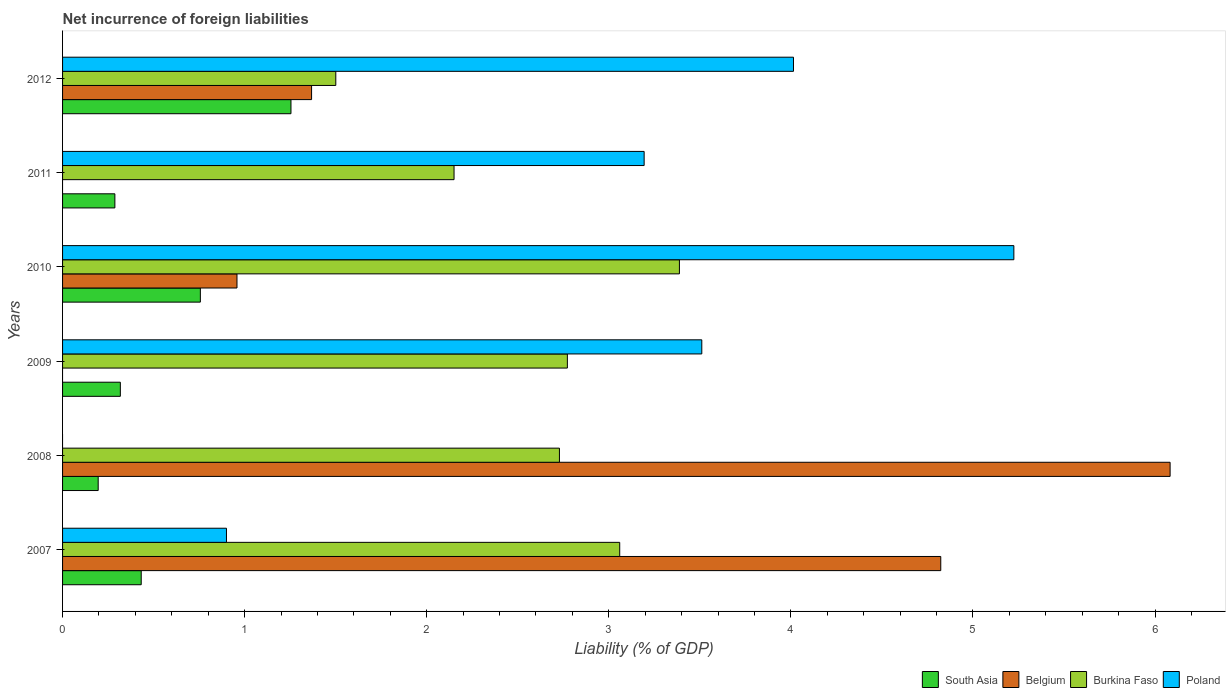How many different coloured bars are there?
Give a very brief answer. 4. Are the number of bars on each tick of the Y-axis equal?
Provide a short and direct response. No. How many bars are there on the 2nd tick from the top?
Your answer should be compact. 3. How many bars are there on the 1st tick from the bottom?
Give a very brief answer. 4. What is the net incurrence of foreign liabilities in Burkina Faso in 2007?
Keep it short and to the point. 3.06. Across all years, what is the maximum net incurrence of foreign liabilities in Belgium?
Provide a succinct answer. 6.08. In which year was the net incurrence of foreign liabilities in Burkina Faso maximum?
Your answer should be compact. 2010. What is the total net incurrence of foreign liabilities in South Asia in the graph?
Ensure brevity in your answer.  3.24. What is the difference between the net incurrence of foreign liabilities in Poland in 2010 and that in 2011?
Ensure brevity in your answer.  2.03. What is the difference between the net incurrence of foreign liabilities in Poland in 2011 and the net incurrence of foreign liabilities in Belgium in 2007?
Provide a succinct answer. -1.63. What is the average net incurrence of foreign liabilities in Burkina Faso per year?
Offer a terse response. 2.6. In the year 2009, what is the difference between the net incurrence of foreign liabilities in Poland and net incurrence of foreign liabilities in Burkina Faso?
Make the answer very short. 0.74. What is the ratio of the net incurrence of foreign liabilities in Belgium in 2008 to that in 2010?
Provide a short and direct response. 6.35. Is the difference between the net incurrence of foreign liabilities in Poland in 2007 and 2012 greater than the difference between the net incurrence of foreign liabilities in Burkina Faso in 2007 and 2012?
Your response must be concise. No. What is the difference between the highest and the second highest net incurrence of foreign liabilities in Belgium?
Your response must be concise. 1.26. What is the difference between the highest and the lowest net incurrence of foreign liabilities in South Asia?
Ensure brevity in your answer.  1.06. In how many years, is the net incurrence of foreign liabilities in Burkina Faso greater than the average net incurrence of foreign liabilities in Burkina Faso taken over all years?
Ensure brevity in your answer.  4. Is the sum of the net incurrence of foreign liabilities in Poland in 2007 and 2010 greater than the maximum net incurrence of foreign liabilities in Burkina Faso across all years?
Offer a very short reply. Yes. Is it the case that in every year, the sum of the net incurrence of foreign liabilities in Poland and net incurrence of foreign liabilities in Burkina Faso is greater than the sum of net incurrence of foreign liabilities in Belgium and net incurrence of foreign liabilities in South Asia?
Offer a terse response. No. How many bars are there?
Ensure brevity in your answer.  21. What is the difference between two consecutive major ticks on the X-axis?
Your answer should be compact. 1. Are the values on the major ticks of X-axis written in scientific E-notation?
Provide a succinct answer. No. Does the graph contain any zero values?
Ensure brevity in your answer.  Yes. Does the graph contain grids?
Offer a very short reply. No. Where does the legend appear in the graph?
Offer a terse response. Bottom right. How are the legend labels stacked?
Ensure brevity in your answer.  Horizontal. What is the title of the graph?
Ensure brevity in your answer.  Net incurrence of foreign liabilities. What is the label or title of the X-axis?
Provide a succinct answer. Liability (% of GDP). What is the Liability (% of GDP) of South Asia in 2007?
Offer a very short reply. 0.43. What is the Liability (% of GDP) of Belgium in 2007?
Ensure brevity in your answer.  4.82. What is the Liability (% of GDP) in Burkina Faso in 2007?
Offer a very short reply. 3.06. What is the Liability (% of GDP) in Poland in 2007?
Provide a short and direct response. 0.9. What is the Liability (% of GDP) in South Asia in 2008?
Your answer should be very brief. 0.2. What is the Liability (% of GDP) in Belgium in 2008?
Make the answer very short. 6.08. What is the Liability (% of GDP) in Burkina Faso in 2008?
Offer a terse response. 2.73. What is the Liability (% of GDP) in South Asia in 2009?
Offer a terse response. 0.32. What is the Liability (% of GDP) in Belgium in 2009?
Provide a short and direct response. 0. What is the Liability (% of GDP) in Burkina Faso in 2009?
Ensure brevity in your answer.  2.77. What is the Liability (% of GDP) in Poland in 2009?
Offer a very short reply. 3.51. What is the Liability (% of GDP) in South Asia in 2010?
Give a very brief answer. 0.76. What is the Liability (% of GDP) in Belgium in 2010?
Offer a terse response. 0.96. What is the Liability (% of GDP) of Burkina Faso in 2010?
Your answer should be compact. 3.39. What is the Liability (% of GDP) of Poland in 2010?
Provide a succinct answer. 5.22. What is the Liability (% of GDP) of South Asia in 2011?
Keep it short and to the point. 0.29. What is the Liability (% of GDP) of Belgium in 2011?
Ensure brevity in your answer.  0. What is the Liability (% of GDP) in Burkina Faso in 2011?
Provide a short and direct response. 2.15. What is the Liability (% of GDP) in Poland in 2011?
Provide a short and direct response. 3.19. What is the Liability (% of GDP) in South Asia in 2012?
Your response must be concise. 1.25. What is the Liability (% of GDP) in Belgium in 2012?
Make the answer very short. 1.37. What is the Liability (% of GDP) of Burkina Faso in 2012?
Your response must be concise. 1.5. What is the Liability (% of GDP) of Poland in 2012?
Offer a very short reply. 4.01. Across all years, what is the maximum Liability (% of GDP) of South Asia?
Your response must be concise. 1.25. Across all years, what is the maximum Liability (% of GDP) of Belgium?
Give a very brief answer. 6.08. Across all years, what is the maximum Liability (% of GDP) of Burkina Faso?
Offer a terse response. 3.39. Across all years, what is the maximum Liability (% of GDP) in Poland?
Make the answer very short. 5.22. Across all years, what is the minimum Liability (% of GDP) in South Asia?
Your answer should be very brief. 0.2. Across all years, what is the minimum Liability (% of GDP) in Burkina Faso?
Keep it short and to the point. 1.5. Across all years, what is the minimum Liability (% of GDP) of Poland?
Make the answer very short. 0. What is the total Liability (% of GDP) of South Asia in the graph?
Ensure brevity in your answer.  3.24. What is the total Liability (% of GDP) in Belgium in the graph?
Offer a terse response. 13.23. What is the total Liability (% of GDP) in Burkina Faso in the graph?
Offer a terse response. 15.6. What is the total Liability (% of GDP) in Poland in the graph?
Your response must be concise. 16.84. What is the difference between the Liability (% of GDP) of South Asia in 2007 and that in 2008?
Your answer should be very brief. 0.24. What is the difference between the Liability (% of GDP) in Belgium in 2007 and that in 2008?
Keep it short and to the point. -1.26. What is the difference between the Liability (% of GDP) of Burkina Faso in 2007 and that in 2008?
Make the answer very short. 0.33. What is the difference between the Liability (% of GDP) of South Asia in 2007 and that in 2009?
Provide a short and direct response. 0.11. What is the difference between the Liability (% of GDP) of Burkina Faso in 2007 and that in 2009?
Keep it short and to the point. 0.29. What is the difference between the Liability (% of GDP) of Poland in 2007 and that in 2009?
Keep it short and to the point. -2.61. What is the difference between the Liability (% of GDP) in South Asia in 2007 and that in 2010?
Keep it short and to the point. -0.32. What is the difference between the Liability (% of GDP) of Belgium in 2007 and that in 2010?
Ensure brevity in your answer.  3.87. What is the difference between the Liability (% of GDP) in Burkina Faso in 2007 and that in 2010?
Offer a very short reply. -0.33. What is the difference between the Liability (% of GDP) in Poland in 2007 and that in 2010?
Provide a short and direct response. -4.32. What is the difference between the Liability (% of GDP) of South Asia in 2007 and that in 2011?
Your answer should be very brief. 0.14. What is the difference between the Liability (% of GDP) of Burkina Faso in 2007 and that in 2011?
Give a very brief answer. 0.91. What is the difference between the Liability (% of GDP) of Poland in 2007 and that in 2011?
Provide a succinct answer. -2.29. What is the difference between the Liability (% of GDP) in South Asia in 2007 and that in 2012?
Provide a succinct answer. -0.82. What is the difference between the Liability (% of GDP) in Belgium in 2007 and that in 2012?
Give a very brief answer. 3.46. What is the difference between the Liability (% of GDP) in Burkina Faso in 2007 and that in 2012?
Give a very brief answer. 1.56. What is the difference between the Liability (% of GDP) in Poland in 2007 and that in 2012?
Give a very brief answer. -3.11. What is the difference between the Liability (% of GDP) in South Asia in 2008 and that in 2009?
Ensure brevity in your answer.  -0.12. What is the difference between the Liability (% of GDP) of Burkina Faso in 2008 and that in 2009?
Your answer should be compact. -0.04. What is the difference between the Liability (% of GDP) of South Asia in 2008 and that in 2010?
Your response must be concise. -0.56. What is the difference between the Liability (% of GDP) of Belgium in 2008 and that in 2010?
Your answer should be compact. 5.12. What is the difference between the Liability (% of GDP) of Burkina Faso in 2008 and that in 2010?
Your answer should be very brief. -0.66. What is the difference between the Liability (% of GDP) of South Asia in 2008 and that in 2011?
Offer a very short reply. -0.09. What is the difference between the Liability (% of GDP) of Burkina Faso in 2008 and that in 2011?
Keep it short and to the point. 0.58. What is the difference between the Liability (% of GDP) of South Asia in 2008 and that in 2012?
Provide a succinct answer. -1.06. What is the difference between the Liability (% of GDP) in Belgium in 2008 and that in 2012?
Your answer should be compact. 4.72. What is the difference between the Liability (% of GDP) in Burkina Faso in 2008 and that in 2012?
Your response must be concise. 1.23. What is the difference between the Liability (% of GDP) in South Asia in 2009 and that in 2010?
Provide a short and direct response. -0.44. What is the difference between the Liability (% of GDP) of Burkina Faso in 2009 and that in 2010?
Keep it short and to the point. -0.62. What is the difference between the Liability (% of GDP) in Poland in 2009 and that in 2010?
Give a very brief answer. -1.71. What is the difference between the Liability (% of GDP) of Burkina Faso in 2009 and that in 2011?
Make the answer very short. 0.62. What is the difference between the Liability (% of GDP) in Poland in 2009 and that in 2011?
Your response must be concise. 0.32. What is the difference between the Liability (% of GDP) of South Asia in 2009 and that in 2012?
Provide a short and direct response. -0.94. What is the difference between the Liability (% of GDP) of Burkina Faso in 2009 and that in 2012?
Ensure brevity in your answer.  1.27. What is the difference between the Liability (% of GDP) in Poland in 2009 and that in 2012?
Your answer should be compact. -0.5. What is the difference between the Liability (% of GDP) in South Asia in 2010 and that in 2011?
Ensure brevity in your answer.  0.47. What is the difference between the Liability (% of GDP) of Burkina Faso in 2010 and that in 2011?
Offer a terse response. 1.24. What is the difference between the Liability (% of GDP) in Poland in 2010 and that in 2011?
Keep it short and to the point. 2.03. What is the difference between the Liability (% of GDP) of South Asia in 2010 and that in 2012?
Keep it short and to the point. -0.5. What is the difference between the Liability (% of GDP) of Belgium in 2010 and that in 2012?
Provide a short and direct response. -0.41. What is the difference between the Liability (% of GDP) in Burkina Faso in 2010 and that in 2012?
Provide a succinct answer. 1.89. What is the difference between the Liability (% of GDP) in Poland in 2010 and that in 2012?
Your answer should be very brief. 1.21. What is the difference between the Liability (% of GDP) of South Asia in 2011 and that in 2012?
Keep it short and to the point. -0.97. What is the difference between the Liability (% of GDP) in Burkina Faso in 2011 and that in 2012?
Offer a very short reply. 0.65. What is the difference between the Liability (% of GDP) in Poland in 2011 and that in 2012?
Make the answer very short. -0.82. What is the difference between the Liability (% of GDP) in South Asia in 2007 and the Liability (% of GDP) in Belgium in 2008?
Make the answer very short. -5.65. What is the difference between the Liability (% of GDP) in South Asia in 2007 and the Liability (% of GDP) in Burkina Faso in 2008?
Offer a very short reply. -2.3. What is the difference between the Liability (% of GDP) of Belgium in 2007 and the Liability (% of GDP) of Burkina Faso in 2008?
Keep it short and to the point. 2.09. What is the difference between the Liability (% of GDP) of South Asia in 2007 and the Liability (% of GDP) of Burkina Faso in 2009?
Give a very brief answer. -2.34. What is the difference between the Liability (% of GDP) in South Asia in 2007 and the Liability (% of GDP) in Poland in 2009?
Provide a short and direct response. -3.08. What is the difference between the Liability (% of GDP) in Belgium in 2007 and the Liability (% of GDP) in Burkina Faso in 2009?
Provide a short and direct response. 2.05. What is the difference between the Liability (% of GDP) of Belgium in 2007 and the Liability (% of GDP) of Poland in 2009?
Make the answer very short. 1.31. What is the difference between the Liability (% of GDP) in Burkina Faso in 2007 and the Liability (% of GDP) in Poland in 2009?
Ensure brevity in your answer.  -0.45. What is the difference between the Liability (% of GDP) of South Asia in 2007 and the Liability (% of GDP) of Belgium in 2010?
Ensure brevity in your answer.  -0.53. What is the difference between the Liability (% of GDP) of South Asia in 2007 and the Liability (% of GDP) of Burkina Faso in 2010?
Your answer should be compact. -2.96. What is the difference between the Liability (% of GDP) in South Asia in 2007 and the Liability (% of GDP) in Poland in 2010?
Ensure brevity in your answer.  -4.79. What is the difference between the Liability (% of GDP) in Belgium in 2007 and the Liability (% of GDP) in Burkina Faso in 2010?
Your response must be concise. 1.44. What is the difference between the Liability (% of GDP) in Belgium in 2007 and the Liability (% of GDP) in Poland in 2010?
Provide a succinct answer. -0.4. What is the difference between the Liability (% of GDP) of Burkina Faso in 2007 and the Liability (% of GDP) of Poland in 2010?
Offer a very short reply. -2.16. What is the difference between the Liability (% of GDP) of South Asia in 2007 and the Liability (% of GDP) of Burkina Faso in 2011?
Your response must be concise. -1.72. What is the difference between the Liability (% of GDP) of South Asia in 2007 and the Liability (% of GDP) of Poland in 2011?
Your answer should be compact. -2.76. What is the difference between the Liability (% of GDP) in Belgium in 2007 and the Liability (% of GDP) in Burkina Faso in 2011?
Offer a very short reply. 2.67. What is the difference between the Liability (% of GDP) in Belgium in 2007 and the Liability (% of GDP) in Poland in 2011?
Ensure brevity in your answer.  1.63. What is the difference between the Liability (% of GDP) of Burkina Faso in 2007 and the Liability (% of GDP) of Poland in 2011?
Your answer should be very brief. -0.13. What is the difference between the Liability (% of GDP) in South Asia in 2007 and the Liability (% of GDP) in Belgium in 2012?
Offer a terse response. -0.94. What is the difference between the Liability (% of GDP) in South Asia in 2007 and the Liability (% of GDP) in Burkina Faso in 2012?
Offer a terse response. -1.07. What is the difference between the Liability (% of GDP) in South Asia in 2007 and the Liability (% of GDP) in Poland in 2012?
Provide a succinct answer. -3.58. What is the difference between the Liability (% of GDP) of Belgium in 2007 and the Liability (% of GDP) of Burkina Faso in 2012?
Ensure brevity in your answer.  3.32. What is the difference between the Liability (% of GDP) of Belgium in 2007 and the Liability (% of GDP) of Poland in 2012?
Your answer should be very brief. 0.81. What is the difference between the Liability (% of GDP) of Burkina Faso in 2007 and the Liability (% of GDP) of Poland in 2012?
Give a very brief answer. -0.95. What is the difference between the Liability (% of GDP) in South Asia in 2008 and the Liability (% of GDP) in Burkina Faso in 2009?
Give a very brief answer. -2.58. What is the difference between the Liability (% of GDP) of South Asia in 2008 and the Liability (% of GDP) of Poland in 2009?
Your response must be concise. -3.32. What is the difference between the Liability (% of GDP) of Belgium in 2008 and the Liability (% of GDP) of Burkina Faso in 2009?
Your answer should be very brief. 3.31. What is the difference between the Liability (% of GDP) of Belgium in 2008 and the Liability (% of GDP) of Poland in 2009?
Give a very brief answer. 2.57. What is the difference between the Liability (% of GDP) in Burkina Faso in 2008 and the Liability (% of GDP) in Poland in 2009?
Your answer should be very brief. -0.78. What is the difference between the Liability (% of GDP) in South Asia in 2008 and the Liability (% of GDP) in Belgium in 2010?
Your answer should be very brief. -0.76. What is the difference between the Liability (% of GDP) of South Asia in 2008 and the Liability (% of GDP) of Burkina Faso in 2010?
Provide a succinct answer. -3.19. What is the difference between the Liability (% of GDP) in South Asia in 2008 and the Liability (% of GDP) in Poland in 2010?
Make the answer very short. -5.03. What is the difference between the Liability (% of GDP) in Belgium in 2008 and the Liability (% of GDP) in Burkina Faso in 2010?
Offer a very short reply. 2.69. What is the difference between the Liability (% of GDP) in Belgium in 2008 and the Liability (% of GDP) in Poland in 2010?
Offer a very short reply. 0.86. What is the difference between the Liability (% of GDP) of Burkina Faso in 2008 and the Liability (% of GDP) of Poland in 2010?
Offer a terse response. -2.5. What is the difference between the Liability (% of GDP) in South Asia in 2008 and the Liability (% of GDP) in Burkina Faso in 2011?
Make the answer very short. -1.95. What is the difference between the Liability (% of GDP) in South Asia in 2008 and the Liability (% of GDP) in Poland in 2011?
Your answer should be compact. -3. What is the difference between the Liability (% of GDP) in Belgium in 2008 and the Liability (% of GDP) in Burkina Faso in 2011?
Ensure brevity in your answer.  3.93. What is the difference between the Liability (% of GDP) of Belgium in 2008 and the Liability (% of GDP) of Poland in 2011?
Ensure brevity in your answer.  2.89. What is the difference between the Liability (% of GDP) of Burkina Faso in 2008 and the Liability (% of GDP) of Poland in 2011?
Offer a very short reply. -0.47. What is the difference between the Liability (% of GDP) of South Asia in 2008 and the Liability (% of GDP) of Belgium in 2012?
Keep it short and to the point. -1.17. What is the difference between the Liability (% of GDP) of South Asia in 2008 and the Liability (% of GDP) of Burkina Faso in 2012?
Keep it short and to the point. -1.3. What is the difference between the Liability (% of GDP) in South Asia in 2008 and the Liability (% of GDP) in Poland in 2012?
Ensure brevity in your answer.  -3.82. What is the difference between the Liability (% of GDP) of Belgium in 2008 and the Liability (% of GDP) of Burkina Faso in 2012?
Ensure brevity in your answer.  4.58. What is the difference between the Liability (% of GDP) of Belgium in 2008 and the Liability (% of GDP) of Poland in 2012?
Your answer should be compact. 2.07. What is the difference between the Liability (% of GDP) in Burkina Faso in 2008 and the Liability (% of GDP) in Poland in 2012?
Provide a succinct answer. -1.29. What is the difference between the Liability (% of GDP) in South Asia in 2009 and the Liability (% of GDP) in Belgium in 2010?
Your answer should be very brief. -0.64. What is the difference between the Liability (% of GDP) in South Asia in 2009 and the Liability (% of GDP) in Burkina Faso in 2010?
Provide a succinct answer. -3.07. What is the difference between the Liability (% of GDP) of South Asia in 2009 and the Liability (% of GDP) of Poland in 2010?
Your answer should be compact. -4.91. What is the difference between the Liability (% of GDP) in Burkina Faso in 2009 and the Liability (% of GDP) in Poland in 2010?
Offer a terse response. -2.45. What is the difference between the Liability (% of GDP) in South Asia in 2009 and the Liability (% of GDP) in Burkina Faso in 2011?
Your answer should be very brief. -1.83. What is the difference between the Liability (% of GDP) in South Asia in 2009 and the Liability (% of GDP) in Poland in 2011?
Keep it short and to the point. -2.88. What is the difference between the Liability (% of GDP) of Burkina Faso in 2009 and the Liability (% of GDP) of Poland in 2011?
Provide a succinct answer. -0.42. What is the difference between the Liability (% of GDP) in South Asia in 2009 and the Liability (% of GDP) in Belgium in 2012?
Provide a succinct answer. -1.05. What is the difference between the Liability (% of GDP) of South Asia in 2009 and the Liability (% of GDP) of Burkina Faso in 2012?
Keep it short and to the point. -1.18. What is the difference between the Liability (% of GDP) in South Asia in 2009 and the Liability (% of GDP) in Poland in 2012?
Your answer should be very brief. -3.7. What is the difference between the Liability (% of GDP) in Burkina Faso in 2009 and the Liability (% of GDP) in Poland in 2012?
Provide a short and direct response. -1.24. What is the difference between the Liability (% of GDP) of South Asia in 2010 and the Liability (% of GDP) of Burkina Faso in 2011?
Your answer should be very brief. -1.39. What is the difference between the Liability (% of GDP) of South Asia in 2010 and the Liability (% of GDP) of Poland in 2011?
Your answer should be very brief. -2.44. What is the difference between the Liability (% of GDP) of Belgium in 2010 and the Liability (% of GDP) of Burkina Faso in 2011?
Offer a terse response. -1.19. What is the difference between the Liability (% of GDP) in Belgium in 2010 and the Liability (% of GDP) in Poland in 2011?
Your answer should be very brief. -2.24. What is the difference between the Liability (% of GDP) in Burkina Faso in 2010 and the Liability (% of GDP) in Poland in 2011?
Ensure brevity in your answer.  0.19. What is the difference between the Liability (% of GDP) of South Asia in 2010 and the Liability (% of GDP) of Belgium in 2012?
Offer a very short reply. -0.61. What is the difference between the Liability (% of GDP) of South Asia in 2010 and the Liability (% of GDP) of Burkina Faso in 2012?
Keep it short and to the point. -0.74. What is the difference between the Liability (% of GDP) of South Asia in 2010 and the Liability (% of GDP) of Poland in 2012?
Your answer should be very brief. -3.26. What is the difference between the Liability (% of GDP) in Belgium in 2010 and the Liability (% of GDP) in Burkina Faso in 2012?
Offer a very short reply. -0.54. What is the difference between the Liability (% of GDP) of Belgium in 2010 and the Liability (% of GDP) of Poland in 2012?
Provide a succinct answer. -3.06. What is the difference between the Liability (% of GDP) in Burkina Faso in 2010 and the Liability (% of GDP) in Poland in 2012?
Make the answer very short. -0.63. What is the difference between the Liability (% of GDP) of South Asia in 2011 and the Liability (% of GDP) of Belgium in 2012?
Provide a succinct answer. -1.08. What is the difference between the Liability (% of GDP) of South Asia in 2011 and the Liability (% of GDP) of Burkina Faso in 2012?
Provide a succinct answer. -1.21. What is the difference between the Liability (% of GDP) of South Asia in 2011 and the Liability (% of GDP) of Poland in 2012?
Offer a very short reply. -3.73. What is the difference between the Liability (% of GDP) in Burkina Faso in 2011 and the Liability (% of GDP) in Poland in 2012?
Offer a terse response. -1.86. What is the average Liability (% of GDP) of South Asia per year?
Keep it short and to the point. 0.54. What is the average Liability (% of GDP) of Belgium per year?
Keep it short and to the point. 2.21. What is the average Liability (% of GDP) of Poland per year?
Offer a very short reply. 2.81. In the year 2007, what is the difference between the Liability (% of GDP) of South Asia and Liability (% of GDP) of Belgium?
Make the answer very short. -4.39. In the year 2007, what is the difference between the Liability (% of GDP) in South Asia and Liability (% of GDP) in Burkina Faso?
Make the answer very short. -2.63. In the year 2007, what is the difference between the Liability (% of GDP) of South Asia and Liability (% of GDP) of Poland?
Your answer should be compact. -0.47. In the year 2007, what is the difference between the Liability (% of GDP) in Belgium and Liability (% of GDP) in Burkina Faso?
Give a very brief answer. 1.76. In the year 2007, what is the difference between the Liability (% of GDP) in Belgium and Liability (% of GDP) in Poland?
Make the answer very short. 3.92. In the year 2007, what is the difference between the Liability (% of GDP) of Burkina Faso and Liability (% of GDP) of Poland?
Your response must be concise. 2.16. In the year 2008, what is the difference between the Liability (% of GDP) in South Asia and Liability (% of GDP) in Belgium?
Provide a succinct answer. -5.89. In the year 2008, what is the difference between the Liability (% of GDP) of South Asia and Liability (% of GDP) of Burkina Faso?
Your answer should be very brief. -2.53. In the year 2008, what is the difference between the Liability (% of GDP) of Belgium and Liability (% of GDP) of Burkina Faso?
Offer a very short reply. 3.35. In the year 2009, what is the difference between the Liability (% of GDP) in South Asia and Liability (% of GDP) in Burkina Faso?
Provide a succinct answer. -2.46. In the year 2009, what is the difference between the Liability (% of GDP) of South Asia and Liability (% of GDP) of Poland?
Offer a terse response. -3.19. In the year 2009, what is the difference between the Liability (% of GDP) of Burkina Faso and Liability (% of GDP) of Poland?
Offer a terse response. -0.74. In the year 2010, what is the difference between the Liability (% of GDP) of South Asia and Liability (% of GDP) of Belgium?
Your response must be concise. -0.2. In the year 2010, what is the difference between the Liability (% of GDP) of South Asia and Liability (% of GDP) of Burkina Faso?
Provide a succinct answer. -2.63. In the year 2010, what is the difference between the Liability (% of GDP) in South Asia and Liability (% of GDP) in Poland?
Your answer should be compact. -4.47. In the year 2010, what is the difference between the Liability (% of GDP) of Belgium and Liability (% of GDP) of Burkina Faso?
Ensure brevity in your answer.  -2.43. In the year 2010, what is the difference between the Liability (% of GDP) in Belgium and Liability (% of GDP) in Poland?
Provide a short and direct response. -4.27. In the year 2010, what is the difference between the Liability (% of GDP) of Burkina Faso and Liability (% of GDP) of Poland?
Provide a short and direct response. -1.84. In the year 2011, what is the difference between the Liability (% of GDP) in South Asia and Liability (% of GDP) in Burkina Faso?
Give a very brief answer. -1.86. In the year 2011, what is the difference between the Liability (% of GDP) of South Asia and Liability (% of GDP) of Poland?
Give a very brief answer. -2.91. In the year 2011, what is the difference between the Liability (% of GDP) in Burkina Faso and Liability (% of GDP) in Poland?
Keep it short and to the point. -1.04. In the year 2012, what is the difference between the Liability (% of GDP) of South Asia and Liability (% of GDP) of Belgium?
Provide a short and direct response. -0.11. In the year 2012, what is the difference between the Liability (% of GDP) of South Asia and Liability (% of GDP) of Burkina Faso?
Your response must be concise. -0.25. In the year 2012, what is the difference between the Liability (% of GDP) of South Asia and Liability (% of GDP) of Poland?
Offer a terse response. -2.76. In the year 2012, what is the difference between the Liability (% of GDP) in Belgium and Liability (% of GDP) in Burkina Faso?
Keep it short and to the point. -0.13. In the year 2012, what is the difference between the Liability (% of GDP) in Belgium and Liability (% of GDP) in Poland?
Your response must be concise. -2.65. In the year 2012, what is the difference between the Liability (% of GDP) of Burkina Faso and Liability (% of GDP) of Poland?
Your answer should be very brief. -2.51. What is the ratio of the Liability (% of GDP) in South Asia in 2007 to that in 2008?
Your answer should be very brief. 2.21. What is the ratio of the Liability (% of GDP) in Belgium in 2007 to that in 2008?
Your answer should be very brief. 0.79. What is the ratio of the Liability (% of GDP) of Burkina Faso in 2007 to that in 2008?
Offer a very short reply. 1.12. What is the ratio of the Liability (% of GDP) in South Asia in 2007 to that in 2009?
Provide a short and direct response. 1.36. What is the ratio of the Liability (% of GDP) of Burkina Faso in 2007 to that in 2009?
Your answer should be very brief. 1.1. What is the ratio of the Liability (% of GDP) in Poland in 2007 to that in 2009?
Keep it short and to the point. 0.26. What is the ratio of the Liability (% of GDP) in South Asia in 2007 to that in 2010?
Give a very brief answer. 0.57. What is the ratio of the Liability (% of GDP) of Belgium in 2007 to that in 2010?
Ensure brevity in your answer.  5.03. What is the ratio of the Liability (% of GDP) in Burkina Faso in 2007 to that in 2010?
Provide a succinct answer. 0.9. What is the ratio of the Liability (% of GDP) in Poland in 2007 to that in 2010?
Keep it short and to the point. 0.17. What is the ratio of the Liability (% of GDP) in South Asia in 2007 to that in 2011?
Provide a short and direct response. 1.5. What is the ratio of the Liability (% of GDP) of Burkina Faso in 2007 to that in 2011?
Provide a succinct answer. 1.42. What is the ratio of the Liability (% of GDP) in Poland in 2007 to that in 2011?
Keep it short and to the point. 0.28. What is the ratio of the Liability (% of GDP) in South Asia in 2007 to that in 2012?
Offer a very short reply. 0.34. What is the ratio of the Liability (% of GDP) in Belgium in 2007 to that in 2012?
Your answer should be very brief. 3.53. What is the ratio of the Liability (% of GDP) in Burkina Faso in 2007 to that in 2012?
Your response must be concise. 2.04. What is the ratio of the Liability (% of GDP) in Poland in 2007 to that in 2012?
Your answer should be compact. 0.22. What is the ratio of the Liability (% of GDP) in South Asia in 2008 to that in 2009?
Provide a succinct answer. 0.62. What is the ratio of the Liability (% of GDP) of Burkina Faso in 2008 to that in 2009?
Your response must be concise. 0.98. What is the ratio of the Liability (% of GDP) of South Asia in 2008 to that in 2010?
Give a very brief answer. 0.26. What is the ratio of the Liability (% of GDP) in Belgium in 2008 to that in 2010?
Provide a succinct answer. 6.35. What is the ratio of the Liability (% of GDP) of Burkina Faso in 2008 to that in 2010?
Keep it short and to the point. 0.81. What is the ratio of the Liability (% of GDP) in South Asia in 2008 to that in 2011?
Keep it short and to the point. 0.68. What is the ratio of the Liability (% of GDP) of Burkina Faso in 2008 to that in 2011?
Offer a terse response. 1.27. What is the ratio of the Liability (% of GDP) of South Asia in 2008 to that in 2012?
Provide a short and direct response. 0.16. What is the ratio of the Liability (% of GDP) in Belgium in 2008 to that in 2012?
Your response must be concise. 4.45. What is the ratio of the Liability (% of GDP) in Burkina Faso in 2008 to that in 2012?
Keep it short and to the point. 1.82. What is the ratio of the Liability (% of GDP) of South Asia in 2009 to that in 2010?
Your answer should be very brief. 0.42. What is the ratio of the Liability (% of GDP) of Burkina Faso in 2009 to that in 2010?
Provide a short and direct response. 0.82. What is the ratio of the Liability (% of GDP) of Poland in 2009 to that in 2010?
Keep it short and to the point. 0.67. What is the ratio of the Liability (% of GDP) in South Asia in 2009 to that in 2011?
Your answer should be very brief. 1.1. What is the ratio of the Liability (% of GDP) of Burkina Faso in 2009 to that in 2011?
Offer a very short reply. 1.29. What is the ratio of the Liability (% of GDP) of Poland in 2009 to that in 2011?
Offer a terse response. 1.1. What is the ratio of the Liability (% of GDP) in South Asia in 2009 to that in 2012?
Offer a terse response. 0.25. What is the ratio of the Liability (% of GDP) in Burkina Faso in 2009 to that in 2012?
Provide a short and direct response. 1.85. What is the ratio of the Liability (% of GDP) in Poland in 2009 to that in 2012?
Provide a short and direct response. 0.87. What is the ratio of the Liability (% of GDP) in South Asia in 2010 to that in 2011?
Your response must be concise. 2.63. What is the ratio of the Liability (% of GDP) in Burkina Faso in 2010 to that in 2011?
Your response must be concise. 1.58. What is the ratio of the Liability (% of GDP) of Poland in 2010 to that in 2011?
Keep it short and to the point. 1.64. What is the ratio of the Liability (% of GDP) in South Asia in 2010 to that in 2012?
Offer a terse response. 0.6. What is the ratio of the Liability (% of GDP) in Belgium in 2010 to that in 2012?
Ensure brevity in your answer.  0.7. What is the ratio of the Liability (% of GDP) in Burkina Faso in 2010 to that in 2012?
Provide a succinct answer. 2.26. What is the ratio of the Liability (% of GDP) of Poland in 2010 to that in 2012?
Keep it short and to the point. 1.3. What is the ratio of the Liability (% of GDP) in South Asia in 2011 to that in 2012?
Your answer should be very brief. 0.23. What is the ratio of the Liability (% of GDP) in Burkina Faso in 2011 to that in 2012?
Provide a short and direct response. 1.43. What is the ratio of the Liability (% of GDP) of Poland in 2011 to that in 2012?
Offer a very short reply. 0.8. What is the difference between the highest and the second highest Liability (% of GDP) in South Asia?
Provide a succinct answer. 0.5. What is the difference between the highest and the second highest Liability (% of GDP) in Belgium?
Provide a succinct answer. 1.26. What is the difference between the highest and the second highest Liability (% of GDP) of Burkina Faso?
Provide a short and direct response. 0.33. What is the difference between the highest and the second highest Liability (% of GDP) of Poland?
Provide a short and direct response. 1.21. What is the difference between the highest and the lowest Liability (% of GDP) of South Asia?
Make the answer very short. 1.06. What is the difference between the highest and the lowest Liability (% of GDP) of Belgium?
Offer a terse response. 6.08. What is the difference between the highest and the lowest Liability (% of GDP) of Burkina Faso?
Your answer should be very brief. 1.89. What is the difference between the highest and the lowest Liability (% of GDP) of Poland?
Keep it short and to the point. 5.22. 